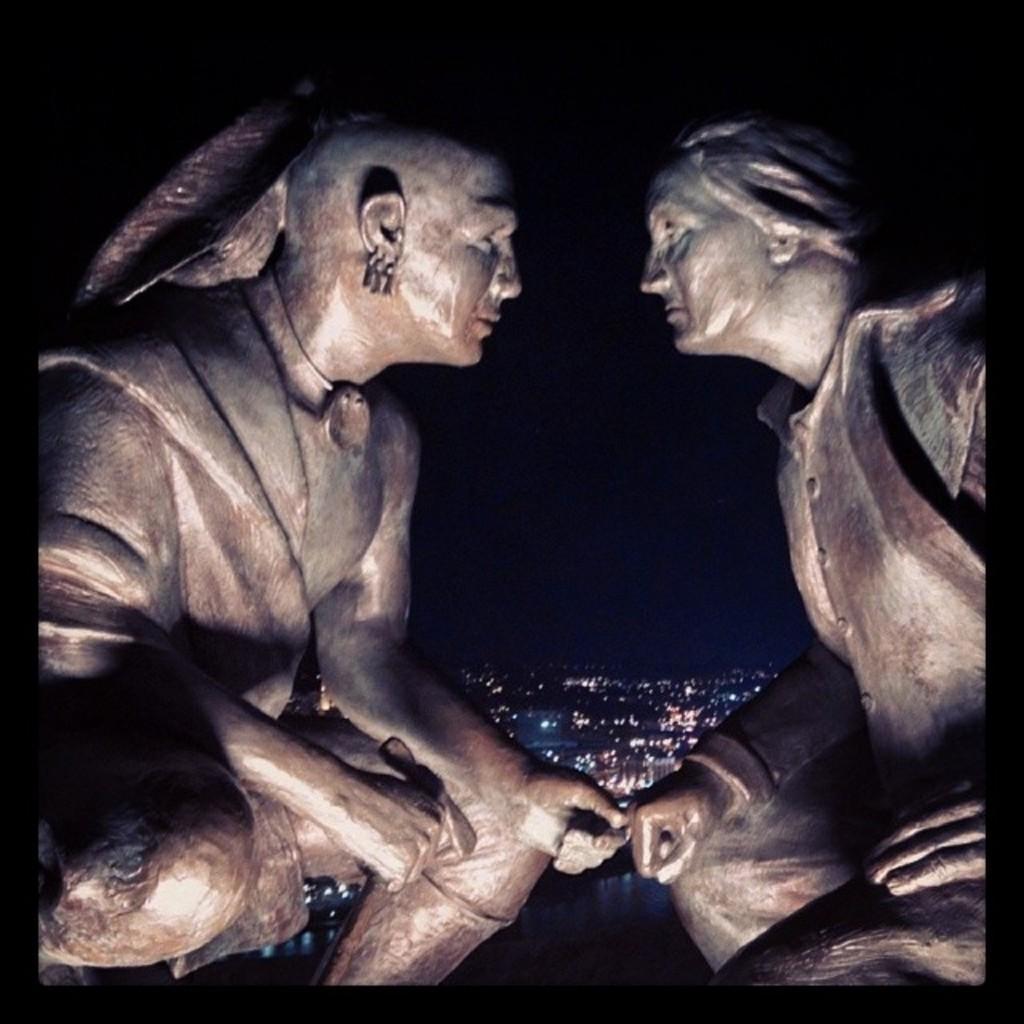How would you summarize this image in a sentence or two? In this image I can see two sculptures in the front. In the background I can see number of lights and I can see this image is little bit in dark. 